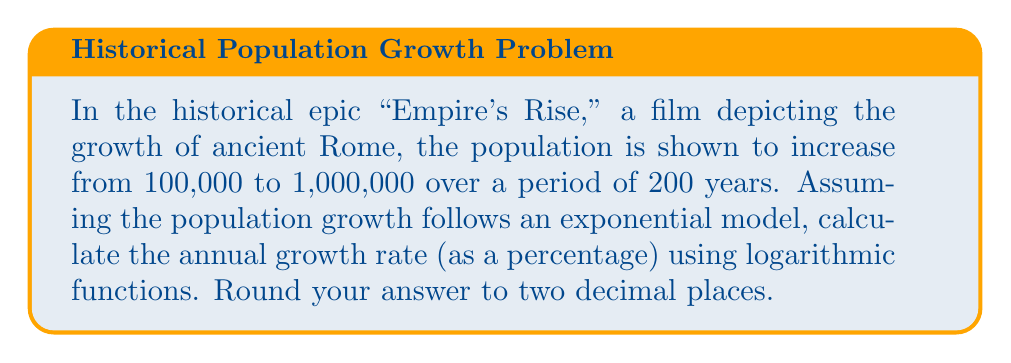Can you solve this math problem? To solve this problem, we'll use the exponential growth formula and logarithms:

1) The exponential growth formula is:
   $A = P(1 + r)^t$
   Where:
   $A$ is the final amount (1,000,000)
   $P$ is the initial amount (100,000)
   $r$ is the annual growth rate (what we're solving for)
   $t$ is the time in years (200)

2) Substituting our values:
   $1,000,000 = 100,000(1 + r)^{200}$

3) Divide both sides by 100,000:
   $10 = (1 + r)^{200}$

4) Take the natural log of both sides:
   $\ln(10) = 200 \ln(1 + r)$

5) Divide both sides by 200:
   $\frac{\ln(10)}{200} = \ln(1 + r)$

6) Take $e$ to the power of both sides:
   $e^{\frac{\ln(10)}{200}} = e^{\ln(1 + r)} = 1 + r$

7) Subtract 1 from both sides:
   $e^{\frac{\ln(10)}{200}} - 1 = r$

8) Calculate:
   $r = e^{\frac{\ln(10)}{200}} - 1 \approx 0.0116$

9) Convert to a percentage:
   $0.0116 \times 100 = 1.16\%$
Answer: The annual population growth rate depicted in the film is approximately 1.16%. 